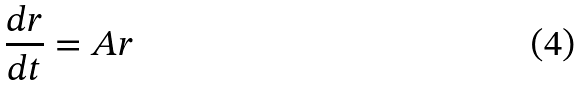Convert formula to latex. <formula><loc_0><loc_0><loc_500><loc_500>\frac { d r } { d t } = A r</formula> 